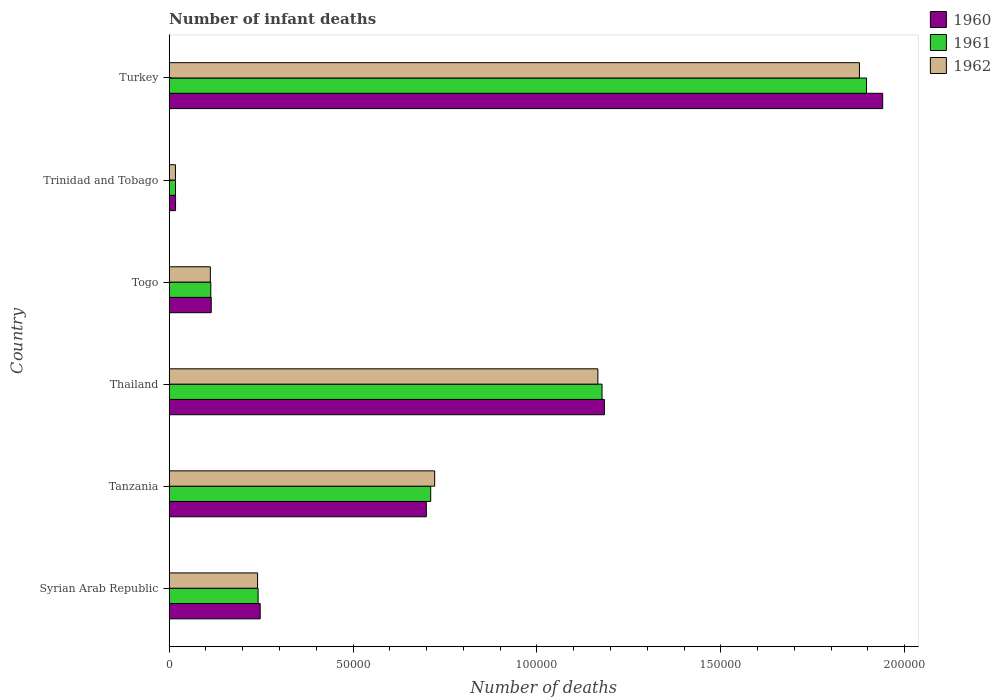How many different coloured bars are there?
Keep it short and to the point. 3. Are the number of bars on each tick of the Y-axis equal?
Keep it short and to the point. Yes. How many bars are there on the 3rd tick from the bottom?
Offer a very short reply. 3. What is the label of the 5th group of bars from the top?
Offer a terse response. Tanzania. What is the number of infant deaths in 1960 in Togo?
Make the answer very short. 1.14e+04. Across all countries, what is the maximum number of infant deaths in 1961?
Provide a succinct answer. 1.90e+05. Across all countries, what is the minimum number of infant deaths in 1962?
Ensure brevity in your answer.  1698. In which country was the number of infant deaths in 1962 maximum?
Offer a very short reply. Turkey. In which country was the number of infant deaths in 1962 minimum?
Provide a succinct answer. Trinidad and Tobago. What is the total number of infant deaths in 1961 in the graph?
Ensure brevity in your answer.  4.16e+05. What is the difference between the number of infant deaths in 1960 in Syrian Arab Republic and that in Trinidad and Tobago?
Give a very brief answer. 2.30e+04. What is the difference between the number of infant deaths in 1961 in Togo and the number of infant deaths in 1962 in Trinidad and Tobago?
Provide a succinct answer. 9613. What is the average number of infant deaths in 1961 per country?
Provide a succinct answer. 6.93e+04. What is the difference between the number of infant deaths in 1962 and number of infant deaths in 1960 in Turkey?
Your answer should be very brief. -6326. In how many countries, is the number of infant deaths in 1960 greater than 30000 ?
Your answer should be compact. 3. What is the ratio of the number of infant deaths in 1962 in Tanzania to that in Turkey?
Your answer should be very brief. 0.38. Is the number of infant deaths in 1961 in Tanzania less than that in Trinidad and Tobago?
Provide a short and direct response. No. What is the difference between the highest and the second highest number of infant deaths in 1962?
Make the answer very short. 7.11e+04. What is the difference between the highest and the lowest number of infant deaths in 1961?
Your answer should be compact. 1.88e+05. Is the sum of the number of infant deaths in 1960 in Tanzania and Turkey greater than the maximum number of infant deaths in 1961 across all countries?
Your answer should be compact. Yes. What does the 3rd bar from the bottom in Turkey represents?
Give a very brief answer. 1962. How many bars are there?
Provide a short and direct response. 18. Are all the bars in the graph horizontal?
Provide a short and direct response. Yes. How many countries are there in the graph?
Keep it short and to the point. 6. What is the difference between two consecutive major ticks on the X-axis?
Your answer should be compact. 5.00e+04. Are the values on the major ticks of X-axis written in scientific E-notation?
Provide a short and direct response. No. Does the graph contain any zero values?
Provide a short and direct response. No. Does the graph contain grids?
Your answer should be very brief. No. What is the title of the graph?
Your response must be concise. Number of infant deaths. Does "1999" appear as one of the legend labels in the graph?
Your response must be concise. No. What is the label or title of the X-axis?
Offer a terse response. Number of deaths. What is the label or title of the Y-axis?
Your response must be concise. Country. What is the Number of deaths in 1960 in Syrian Arab Republic?
Offer a terse response. 2.47e+04. What is the Number of deaths of 1961 in Syrian Arab Republic?
Your answer should be very brief. 2.42e+04. What is the Number of deaths of 1962 in Syrian Arab Republic?
Your answer should be compact. 2.40e+04. What is the Number of deaths of 1960 in Tanzania?
Make the answer very short. 6.99e+04. What is the Number of deaths in 1961 in Tanzania?
Ensure brevity in your answer.  7.11e+04. What is the Number of deaths in 1962 in Tanzania?
Offer a terse response. 7.22e+04. What is the Number of deaths in 1960 in Thailand?
Keep it short and to the point. 1.18e+05. What is the Number of deaths of 1961 in Thailand?
Provide a succinct answer. 1.18e+05. What is the Number of deaths of 1962 in Thailand?
Offer a very short reply. 1.17e+05. What is the Number of deaths in 1960 in Togo?
Your answer should be compact. 1.14e+04. What is the Number of deaths of 1961 in Togo?
Provide a short and direct response. 1.13e+04. What is the Number of deaths of 1962 in Togo?
Give a very brief answer. 1.12e+04. What is the Number of deaths of 1960 in Trinidad and Tobago?
Provide a short and direct response. 1728. What is the Number of deaths in 1961 in Trinidad and Tobago?
Your answer should be compact. 1710. What is the Number of deaths in 1962 in Trinidad and Tobago?
Provide a short and direct response. 1698. What is the Number of deaths in 1960 in Turkey?
Provide a short and direct response. 1.94e+05. What is the Number of deaths of 1961 in Turkey?
Ensure brevity in your answer.  1.90e+05. What is the Number of deaths of 1962 in Turkey?
Provide a short and direct response. 1.88e+05. Across all countries, what is the maximum Number of deaths in 1960?
Make the answer very short. 1.94e+05. Across all countries, what is the maximum Number of deaths of 1961?
Ensure brevity in your answer.  1.90e+05. Across all countries, what is the maximum Number of deaths of 1962?
Offer a terse response. 1.88e+05. Across all countries, what is the minimum Number of deaths in 1960?
Provide a succinct answer. 1728. Across all countries, what is the minimum Number of deaths in 1961?
Your answer should be very brief. 1710. Across all countries, what is the minimum Number of deaths in 1962?
Offer a very short reply. 1698. What is the total Number of deaths in 1960 in the graph?
Give a very brief answer. 4.20e+05. What is the total Number of deaths of 1961 in the graph?
Make the answer very short. 4.16e+05. What is the total Number of deaths of 1962 in the graph?
Provide a succinct answer. 4.13e+05. What is the difference between the Number of deaths of 1960 in Syrian Arab Republic and that in Tanzania?
Offer a terse response. -4.52e+04. What is the difference between the Number of deaths in 1961 in Syrian Arab Republic and that in Tanzania?
Your response must be concise. -4.69e+04. What is the difference between the Number of deaths in 1962 in Syrian Arab Republic and that in Tanzania?
Provide a short and direct response. -4.82e+04. What is the difference between the Number of deaths in 1960 in Syrian Arab Republic and that in Thailand?
Provide a succinct answer. -9.36e+04. What is the difference between the Number of deaths of 1961 in Syrian Arab Republic and that in Thailand?
Provide a succinct answer. -9.35e+04. What is the difference between the Number of deaths of 1962 in Syrian Arab Republic and that in Thailand?
Offer a very short reply. -9.25e+04. What is the difference between the Number of deaths in 1960 in Syrian Arab Republic and that in Togo?
Offer a terse response. 1.33e+04. What is the difference between the Number of deaths of 1961 in Syrian Arab Republic and that in Togo?
Make the answer very short. 1.29e+04. What is the difference between the Number of deaths of 1962 in Syrian Arab Republic and that in Togo?
Make the answer very short. 1.28e+04. What is the difference between the Number of deaths in 1960 in Syrian Arab Republic and that in Trinidad and Tobago?
Your answer should be compact. 2.30e+04. What is the difference between the Number of deaths in 1961 in Syrian Arab Republic and that in Trinidad and Tobago?
Offer a very short reply. 2.25e+04. What is the difference between the Number of deaths in 1962 in Syrian Arab Republic and that in Trinidad and Tobago?
Keep it short and to the point. 2.23e+04. What is the difference between the Number of deaths in 1960 in Syrian Arab Republic and that in Turkey?
Your answer should be compact. -1.69e+05. What is the difference between the Number of deaths of 1961 in Syrian Arab Republic and that in Turkey?
Give a very brief answer. -1.65e+05. What is the difference between the Number of deaths of 1962 in Syrian Arab Republic and that in Turkey?
Keep it short and to the point. -1.64e+05. What is the difference between the Number of deaths of 1960 in Tanzania and that in Thailand?
Keep it short and to the point. -4.84e+04. What is the difference between the Number of deaths in 1961 in Tanzania and that in Thailand?
Provide a succinct answer. -4.66e+04. What is the difference between the Number of deaths of 1962 in Tanzania and that in Thailand?
Provide a short and direct response. -4.44e+04. What is the difference between the Number of deaths in 1960 in Tanzania and that in Togo?
Your answer should be very brief. 5.85e+04. What is the difference between the Number of deaths of 1961 in Tanzania and that in Togo?
Give a very brief answer. 5.98e+04. What is the difference between the Number of deaths in 1962 in Tanzania and that in Togo?
Give a very brief answer. 6.10e+04. What is the difference between the Number of deaths of 1960 in Tanzania and that in Trinidad and Tobago?
Your answer should be compact. 6.82e+04. What is the difference between the Number of deaths in 1961 in Tanzania and that in Trinidad and Tobago?
Provide a succinct answer. 6.94e+04. What is the difference between the Number of deaths in 1962 in Tanzania and that in Trinidad and Tobago?
Offer a very short reply. 7.05e+04. What is the difference between the Number of deaths in 1960 in Tanzania and that in Turkey?
Give a very brief answer. -1.24e+05. What is the difference between the Number of deaths in 1961 in Tanzania and that in Turkey?
Make the answer very short. -1.19e+05. What is the difference between the Number of deaths in 1962 in Tanzania and that in Turkey?
Provide a succinct answer. -1.16e+05. What is the difference between the Number of deaths in 1960 in Thailand and that in Togo?
Offer a terse response. 1.07e+05. What is the difference between the Number of deaths of 1961 in Thailand and that in Togo?
Keep it short and to the point. 1.06e+05. What is the difference between the Number of deaths of 1962 in Thailand and that in Togo?
Your response must be concise. 1.05e+05. What is the difference between the Number of deaths of 1960 in Thailand and that in Trinidad and Tobago?
Your answer should be very brief. 1.17e+05. What is the difference between the Number of deaths of 1961 in Thailand and that in Trinidad and Tobago?
Your response must be concise. 1.16e+05. What is the difference between the Number of deaths in 1962 in Thailand and that in Trinidad and Tobago?
Provide a succinct answer. 1.15e+05. What is the difference between the Number of deaths of 1960 in Thailand and that in Turkey?
Offer a very short reply. -7.57e+04. What is the difference between the Number of deaths of 1961 in Thailand and that in Turkey?
Keep it short and to the point. -7.19e+04. What is the difference between the Number of deaths in 1962 in Thailand and that in Turkey?
Offer a very short reply. -7.11e+04. What is the difference between the Number of deaths of 1960 in Togo and that in Trinidad and Tobago?
Provide a succinct answer. 9703. What is the difference between the Number of deaths of 1961 in Togo and that in Trinidad and Tobago?
Your answer should be compact. 9601. What is the difference between the Number of deaths in 1962 in Togo and that in Trinidad and Tobago?
Offer a terse response. 9487. What is the difference between the Number of deaths of 1960 in Togo and that in Turkey?
Make the answer very short. -1.83e+05. What is the difference between the Number of deaths in 1961 in Togo and that in Turkey?
Provide a succinct answer. -1.78e+05. What is the difference between the Number of deaths of 1962 in Togo and that in Turkey?
Your answer should be very brief. -1.77e+05. What is the difference between the Number of deaths of 1960 in Trinidad and Tobago and that in Turkey?
Your answer should be very brief. -1.92e+05. What is the difference between the Number of deaths in 1961 in Trinidad and Tobago and that in Turkey?
Your answer should be very brief. -1.88e+05. What is the difference between the Number of deaths in 1962 in Trinidad and Tobago and that in Turkey?
Keep it short and to the point. -1.86e+05. What is the difference between the Number of deaths in 1960 in Syrian Arab Republic and the Number of deaths in 1961 in Tanzania?
Give a very brief answer. -4.64e+04. What is the difference between the Number of deaths in 1960 in Syrian Arab Republic and the Number of deaths in 1962 in Tanzania?
Offer a terse response. -4.74e+04. What is the difference between the Number of deaths of 1961 in Syrian Arab Republic and the Number of deaths of 1962 in Tanzania?
Your response must be concise. -4.80e+04. What is the difference between the Number of deaths in 1960 in Syrian Arab Republic and the Number of deaths in 1961 in Thailand?
Offer a terse response. -9.30e+04. What is the difference between the Number of deaths of 1960 in Syrian Arab Republic and the Number of deaths of 1962 in Thailand?
Provide a short and direct response. -9.18e+04. What is the difference between the Number of deaths of 1961 in Syrian Arab Republic and the Number of deaths of 1962 in Thailand?
Ensure brevity in your answer.  -9.24e+04. What is the difference between the Number of deaths in 1960 in Syrian Arab Republic and the Number of deaths in 1961 in Togo?
Your response must be concise. 1.34e+04. What is the difference between the Number of deaths of 1960 in Syrian Arab Republic and the Number of deaths of 1962 in Togo?
Your answer should be compact. 1.36e+04. What is the difference between the Number of deaths of 1961 in Syrian Arab Republic and the Number of deaths of 1962 in Togo?
Offer a terse response. 1.30e+04. What is the difference between the Number of deaths of 1960 in Syrian Arab Republic and the Number of deaths of 1961 in Trinidad and Tobago?
Make the answer very short. 2.30e+04. What is the difference between the Number of deaths in 1960 in Syrian Arab Republic and the Number of deaths in 1962 in Trinidad and Tobago?
Offer a very short reply. 2.30e+04. What is the difference between the Number of deaths in 1961 in Syrian Arab Republic and the Number of deaths in 1962 in Trinidad and Tobago?
Make the answer very short. 2.25e+04. What is the difference between the Number of deaths of 1960 in Syrian Arab Republic and the Number of deaths of 1961 in Turkey?
Provide a short and direct response. -1.65e+05. What is the difference between the Number of deaths of 1960 in Syrian Arab Republic and the Number of deaths of 1962 in Turkey?
Your response must be concise. -1.63e+05. What is the difference between the Number of deaths of 1961 in Syrian Arab Republic and the Number of deaths of 1962 in Turkey?
Provide a succinct answer. -1.64e+05. What is the difference between the Number of deaths in 1960 in Tanzania and the Number of deaths in 1961 in Thailand?
Offer a very short reply. -4.78e+04. What is the difference between the Number of deaths of 1960 in Tanzania and the Number of deaths of 1962 in Thailand?
Offer a terse response. -4.66e+04. What is the difference between the Number of deaths of 1961 in Tanzania and the Number of deaths of 1962 in Thailand?
Make the answer very short. -4.55e+04. What is the difference between the Number of deaths in 1960 in Tanzania and the Number of deaths in 1961 in Togo?
Give a very brief answer. 5.86e+04. What is the difference between the Number of deaths in 1960 in Tanzania and the Number of deaths in 1962 in Togo?
Provide a short and direct response. 5.87e+04. What is the difference between the Number of deaths of 1961 in Tanzania and the Number of deaths of 1962 in Togo?
Ensure brevity in your answer.  5.99e+04. What is the difference between the Number of deaths of 1960 in Tanzania and the Number of deaths of 1961 in Trinidad and Tobago?
Provide a succinct answer. 6.82e+04. What is the difference between the Number of deaths of 1960 in Tanzania and the Number of deaths of 1962 in Trinidad and Tobago?
Provide a short and direct response. 6.82e+04. What is the difference between the Number of deaths in 1961 in Tanzania and the Number of deaths in 1962 in Trinidad and Tobago?
Offer a terse response. 6.94e+04. What is the difference between the Number of deaths in 1960 in Tanzania and the Number of deaths in 1961 in Turkey?
Provide a short and direct response. -1.20e+05. What is the difference between the Number of deaths in 1960 in Tanzania and the Number of deaths in 1962 in Turkey?
Provide a succinct answer. -1.18e+05. What is the difference between the Number of deaths in 1961 in Tanzania and the Number of deaths in 1962 in Turkey?
Provide a short and direct response. -1.17e+05. What is the difference between the Number of deaths of 1960 in Thailand and the Number of deaths of 1961 in Togo?
Offer a very short reply. 1.07e+05. What is the difference between the Number of deaths of 1960 in Thailand and the Number of deaths of 1962 in Togo?
Provide a short and direct response. 1.07e+05. What is the difference between the Number of deaths of 1961 in Thailand and the Number of deaths of 1962 in Togo?
Give a very brief answer. 1.07e+05. What is the difference between the Number of deaths in 1960 in Thailand and the Number of deaths in 1961 in Trinidad and Tobago?
Ensure brevity in your answer.  1.17e+05. What is the difference between the Number of deaths in 1960 in Thailand and the Number of deaths in 1962 in Trinidad and Tobago?
Ensure brevity in your answer.  1.17e+05. What is the difference between the Number of deaths in 1961 in Thailand and the Number of deaths in 1962 in Trinidad and Tobago?
Ensure brevity in your answer.  1.16e+05. What is the difference between the Number of deaths of 1960 in Thailand and the Number of deaths of 1961 in Turkey?
Offer a very short reply. -7.13e+04. What is the difference between the Number of deaths of 1960 in Thailand and the Number of deaths of 1962 in Turkey?
Keep it short and to the point. -6.93e+04. What is the difference between the Number of deaths of 1961 in Thailand and the Number of deaths of 1962 in Turkey?
Provide a short and direct response. -7.00e+04. What is the difference between the Number of deaths in 1960 in Togo and the Number of deaths in 1961 in Trinidad and Tobago?
Your response must be concise. 9721. What is the difference between the Number of deaths in 1960 in Togo and the Number of deaths in 1962 in Trinidad and Tobago?
Give a very brief answer. 9733. What is the difference between the Number of deaths of 1961 in Togo and the Number of deaths of 1962 in Trinidad and Tobago?
Your answer should be very brief. 9613. What is the difference between the Number of deaths of 1960 in Togo and the Number of deaths of 1961 in Turkey?
Keep it short and to the point. -1.78e+05. What is the difference between the Number of deaths in 1960 in Togo and the Number of deaths in 1962 in Turkey?
Offer a terse response. -1.76e+05. What is the difference between the Number of deaths in 1961 in Togo and the Number of deaths in 1962 in Turkey?
Your answer should be compact. -1.76e+05. What is the difference between the Number of deaths of 1960 in Trinidad and Tobago and the Number of deaths of 1961 in Turkey?
Offer a terse response. -1.88e+05. What is the difference between the Number of deaths in 1960 in Trinidad and Tobago and the Number of deaths in 1962 in Turkey?
Offer a terse response. -1.86e+05. What is the difference between the Number of deaths of 1961 in Trinidad and Tobago and the Number of deaths of 1962 in Turkey?
Give a very brief answer. -1.86e+05. What is the average Number of deaths in 1960 per country?
Offer a very short reply. 7.00e+04. What is the average Number of deaths in 1961 per country?
Give a very brief answer. 6.93e+04. What is the average Number of deaths of 1962 per country?
Make the answer very short. 6.89e+04. What is the difference between the Number of deaths in 1960 and Number of deaths in 1961 in Syrian Arab Republic?
Provide a succinct answer. 572. What is the difference between the Number of deaths of 1960 and Number of deaths of 1962 in Syrian Arab Republic?
Provide a short and direct response. 711. What is the difference between the Number of deaths of 1961 and Number of deaths of 1962 in Syrian Arab Republic?
Your answer should be compact. 139. What is the difference between the Number of deaths in 1960 and Number of deaths in 1961 in Tanzania?
Your response must be concise. -1186. What is the difference between the Number of deaths of 1960 and Number of deaths of 1962 in Tanzania?
Offer a terse response. -2266. What is the difference between the Number of deaths in 1961 and Number of deaths in 1962 in Tanzania?
Give a very brief answer. -1080. What is the difference between the Number of deaths in 1960 and Number of deaths in 1961 in Thailand?
Your response must be concise. 643. What is the difference between the Number of deaths in 1960 and Number of deaths in 1962 in Thailand?
Give a very brief answer. 1775. What is the difference between the Number of deaths in 1961 and Number of deaths in 1962 in Thailand?
Ensure brevity in your answer.  1132. What is the difference between the Number of deaths in 1960 and Number of deaths in 1961 in Togo?
Give a very brief answer. 120. What is the difference between the Number of deaths in 1960 and Number of deaths in 1962 in Togo?
Ensure brevity in your answer.  246. What is the difference between the Number of deaths in 1961 and Number of deaths in 1962 in Togo?
Keep it short and to the point. 126. What is the difference between the Number of deaths in 1960 and Number of deaths in 1961 in Trinidad and Tobago?
Keep it short and to the point. 18. What is the difference between the Number of deaths of 1960 and Number of deaths of 1962 in Trinidad and Tobago?
Offer a terse response. 30. What is the difference between the Number of deaths in 1960 and Number of deaths in 1961 in Turkey?
Your response must be concise. 4395. What is the difference between the Number of deaths in 1960 and Number of deaths in 1962 in Turkey?
Provide a succinct answer. 6326. What is the difference between the Number of deaths of 1961 and Number of deaths of 1962 in Turkey?
Make the answer very short. 1931. What is the ratio of the Number of deaths of 1960 in Syrian Arab Republic to that in Tanzania?
Provide a short and direct response. 0.35. What is the ratio of the Number of deaths in 1961 in Syrian Arab Republic to that in Tanzania?
Provide a succinct answer. 0.34. What is the ratio of the Number of deaths in 1962 in Syrian Arab Republic to that in Tanzania?
Your response must be concise. 0.33. What is the ratio of the Number of deaths in 1960 in Syrian Arab Republic to that in Thailand?
Keep it short and to the point. 0.21. What is the ratio of the Number of deaths of 1961 in Syrian Arab Republic to that in Thailand?
Offer a terse response. 0.21. What is the ratio of the Number of deaths of 1962 in Syrian Arab Republic to that in Thailand?
Make the answer very short. 0.21. What is the ratio of the Number of deaths in 1960 in Syrian Arab Republic to that in Togo?
Your response must be concise. 2.16. What is the ratio of the Number of deaths of 1961 in Syrian Arab Republic to that in Togo?
Offer a very short reply. 2.14. What is the ratio of the Number of deaths in 1962 in Syrian Arab Republic to that in Togo?
Offer a very short reply. 2.15. What is the ratio of the Number of deaths in 1960 in Syrian Arab Republic to that in Trinidad and Tobago?
Provide a short and direct response. 14.32. What is the ratio of the Number of deaths of 1961 in Syrian Arab Republic to that in Trinidad and Tobago?
Give a very brief answer. 14.13. What is the ratio of the Number of deaths of 1962 in Syrian Arab Republic to that in Trinidad and Tobago?
Provide a short and direct response. 14.15. What is the ratio of the Number of deaths of 1960 in Syrian Arab Republic to that in Turkey?
Provide a succinct answer. 0.13. What is the ratio of the Number of deaths in 1961 in Syrian Arab Republic to that in Turkey?
Offer a very short reply. 0.13. What is the ratio of the Number of deaths in 1962 in Syrian Arab Republic to that in Turkey?
Provide a short and direct response. 0.13. What is the ratio of the Number of deaths of 1960 in Tanzania to that in Thailand?
Provide a short and direct response. 0.59. What is the ratio of the Number of deaths of 1961 in Tanzania to that in Thailand?
Keep it short and to the point. 0.6. What is the ratio of the Number of deaths of 1962 in Tanzania to that in Thailand?
Offer a very short reply. 0.62. What is the ratio of the Number of deaths in 1960 in Tanzania to that in Togo?
Your response must be concise. 6.12. What is the ratio of the Number of deaths in 1961 in Tanzania to that in Togo?
Provide a short and direct response. 6.29. What is the ratio of the Number of deaths in 1962 in Tanzania to that in Togo?
Your response must be concise. 6.45. What is the ratio of the Number of deaths of 1960 in Tanzania to that in Trinidad and Tobago?
Your answer should be very brief. 40.47. What is the ratio of the Number of deaths in 1961 in Tanzania to that in Trinidad and Tobago?
Your response must be concise. 41.59. What is the ratio of the Number of deaths of 1962 in Tanzania to that in Trinidad and Tobago?
Your answer should be compact. 42.52. What is the ratio of the Number of deaths in 1960 in Tanzania to that in Turkey?
Offer a very short reply. 0.36. What is the ratio of the Number of deaths in 1961 in Tanzania to that in Turkey?
Make the answer very short. 0.38. What is the ratio of the Number of deaths of 1962 in Tanzania to that in Turkey?
Make the answer very short. 0.38. What is the ratio of the Number of deaths of 1960 in Thailand to that in Togo?
Your response must be concise. 10.35. What is the ratio of the Number of deaths in 1961 in Thailand to that in Togo?
Make the answer very short. 10.41. What is the ratio of the Number of deaths of 1962 in Thailand to that in Togo?
Offer a terse response. 10.42. What is the ratio of the Number of deaths in 1960 in Thailand to that in Trinidad and Tobago?
Your answer should be compact. 68.49. What is the ratio of the Number of deaths of 1961 in Thailand to that in Trinidad and Tobago?
Make the answer very short. 68.83. What is the ratio of the Number of deaths in 1962 in Thailand to that in Trinidad and Tobago?
Provide a succinct answer. 68.65. What is the ratio of the Number of deaths in 1960 in Thailand to that in Turkey?
Provide a short and direct response. 0.61. What is the ratio of the Number of deaths in 1961 in Thailand to that in Turkey?
Offer a very short reply. 0.62. What is the ratio of the Number of deaths in 1962 in Thailand to that in Turkey?
Offer a very short reply. 0.62. What is the ratio of the Number of deaths in 1960 in Togo to that in Trinidad and Tobago?
Your answer should be very brief. 6.62. What is the ratio of the Number of deaths in 1961 in Togo to that in Trinidad and Tobago?
Your answer should be very brief. 6.61. What is the ratio of the Number of deaths in 1962 in Togo to that in Trinidad and Tobago?
Your answer should be compact. 6.59. What is the ratio of the Number of deaths of 1960 in Togo to that in Turkey?
Give a very brief answer. 0.06. What is the ratio of the Number of deaths of 1961 in Togo to that in Turkey?
Your answer should be very brief. 0.06. What is the ratio of the Number of deaths in 1962 in Togo to that in Turkey?
Keep it short and to the point. 0.06. What is the ratio of the Number of deaths in 1960 in Trinidad and Tobago to that in Turkey?
Offer a very short reply. 0.01. What is the ratio of the Number of deaths in 1961 in Trinidad and Tobago to that in Turkey?
Offer a very short reply. 0.01. What is the ratio of the Number of deaths in 1962 in Trinidad and Tobago to that in Turkey?
Ensure brevity in your answer.  0.01. What is the difference between the highest and the second highest Number of deaths of 1960?
Offer a terse response. 7.57e+04. What is the difference between the highest and the second highest Number of deaths in 1961?
Provide a succinct answer. 7.19e+04. What is the difference between the highest and the second highest Number of deaths in 1962?
Your answer should be very brief. 7.11e+04. What is the difference between the highest and the lowest Number of deaths in 1960?
Give a very brief answer. 1.92e+05. What is the difference between the highest and the lowest Number of deaths in 1961?
Your answer should be compact. 1.88e+05. What is the difference between the highest and the lowest Number of deaths of 1962?
Ensure brevity in your answer.  1.86e+05. 